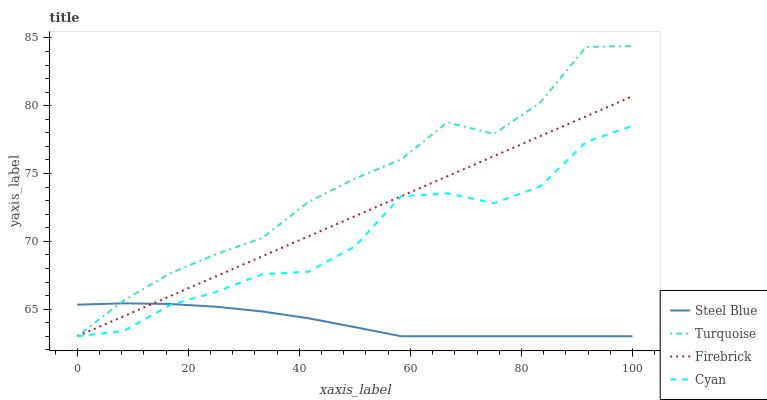Does Steel Blue have the minimum area under the curve?
Answer yes or no. Yes. Does Turquoise have the maximum area under the curve?
Answer yes or no. Yes. Does Turquoise have the minimum area under the curve?
Answer yes or no. No. Does Steel Blue have the maximum area under the curve?
Answer yes or no. No. Is Firebrick the smoothest?
Answer yes or no. Yes. Is Turquoise the roughest?
Answer yes or no. Yes. Is Steel Blue the smoothest?
Answer yes or no. No. Is Steel Blue the roughest?
Answer yes or no. No. Does Firebrick have the lowest value?
Answer yes or no. Yes. Does Turquoise have the highest value?
Answer yes or no. Yes. Does Steel Blue have the highest value?
Answer yes or no. No. Does Steel Blue intersect Turquoise?
Answer yes or no. Yes. Is Steel Blue less than Turquoise?
Answer yes or no. No. Is Steel Blue greater than Turquoise?
Answer yes or no. No. 